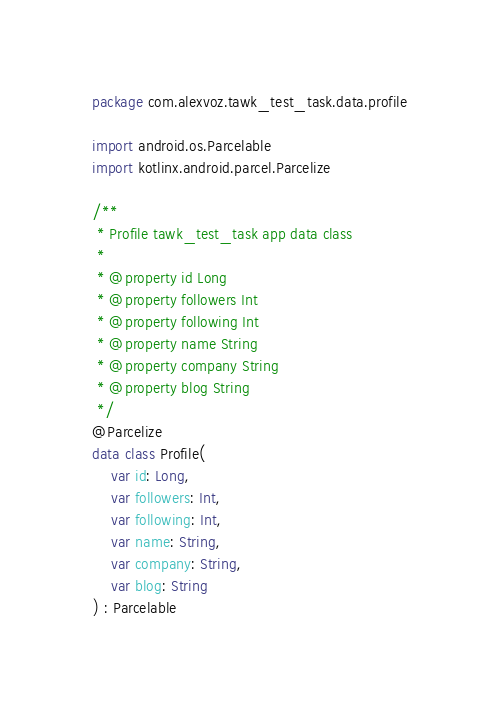Convert code to text. <code><loc_0><loc_0><loc_500><loc_500><_Kotlin_>package com.alexvoz.tawk_test_task.data.profile

import android.os.Parcelable
import kotlinx.android.parcel.Parcelize

/**
 * Profile tawk_test_task app data class
 *
 * @property id Long
 * @property followers Int
 * @property following Int
 * @property name String
 * @property company String
 * @property blog String
 */
@Parcelize
data class Profile(
    var id: Long,
    var followers: Int,
    var following: Int,
    var name: String,
    var company: String,
    var blog: String
) : Parcelable</code> 